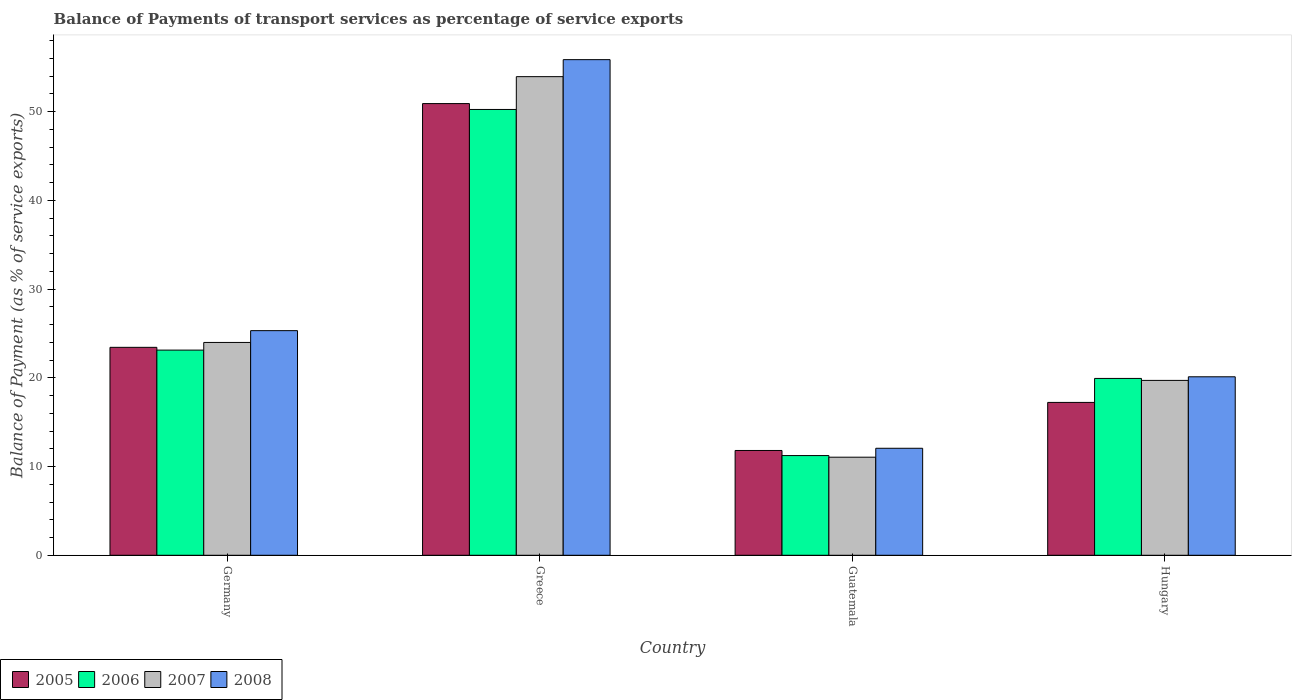How many groups of bars are there?
Your answer should be compact. 4. Are the number of bars per tick equal to the number of legend labels?
Ensure brevity in your answer.  Yes. How many bars are there on the 2nd tick from the left?
Give a very brief answer. 4. What is the balance of payments of transport services in 2008 in Hungary?
Ensure brevity in your answer.  20.12. Across all countries, what is the maximum balance of payments of transport services in 2005?
Provide a succinct answer. 50.92. Across all countries, what is the minimum balance of payments of transport services in 2007?
Make the answer very short. 11.06. In which country was the balance of payments of transport services in 2006 minimum?
Give a very brief answer. Guatemala. What is the total balance of payments of transport services in 2006 in the graph?
Keep it short and to the point. 104.55. What is the difference between the balance of payments of transport services in 2005 in Guatemala and that in Hungary?
Give a very brief answer. -5.42. What is the difference between the balance of payments of transport services in 2006 in Hungary and the balance of payments of transport services in 2008 in Guatemala?
Make the answer very short. 7.87. What is the average balance of payments of transport services in 2007 per country?
Offer a very short reply. 27.18. What is the difference between the balance of payments of transport services of/in 2006 and balance of payments of transport services of/in 2005 in Germany?
Give a very brief answer. -0.31. In how many countries, is the balance of payments of transport services in 2008 greater than 14 %?
Your answer should be compact. 3. What is the ratio of the balance of payments of transport services in 2006 in Guatemala to that in Hungary?
Make the answer very short. 0.56. Is the balance of payments of transport services in 2007 in Guatemala less than that in Hungary?
Provide a short and direct response. Yes. Is the difference between the balance of payments of transport services in 2006 in Germany and Guatemala greater than the difference between the balance of payments of transport services in 2005 in Germany and Guatemala?
Provide a short and direct response. Yes. What is the difference between the highest and the second highest balance of payments of transport services in 2006?
Provide a succinct answer. 30.32. What is the difference between the highest and the lowest balance of payments of transport services in 2006?
Ensure brevity in your answer.  39.02. Is the sum of the balance of payments of transport services in 2007 in Germany and Guatemala greater than the maximum balance of payments of transport services in 2008 across all countries?
Provide a short and direct response. No. Is it the case that in every country, the sum of the balance of payments of transport services in 2007 and balance of payments of transport services in 2008 is greater than the sum of balance of payments of transport services in 2005 and balance of payments of transport services in 2006?
Make the answer very short. No. What does the 4th bar from the left in Hungary represents?
Your answer should be very brief. 2008. How many countries are there in the graph?
Your response must be concise. 4. What is the difference between two consecutive major ticks on the Y-axis?
Offer a very short reply. 10. Does the graph contain any zero values?
Provide a succinct answer. No. Does the graph contain grids?
Your answer should be very brief. No. How many legend labels are there?
Your answer should be very brief. 4. What is the title of the graph?
Your answer should be compact. Balance of Payments of transport services as percentage of service exports. What is the label or title of the X-axis?
Make the answer very short. Country. What is the label or title of the Y-axis?
Your response must be concise. Balance of Payment (as % of service exports). What is the Balance of Payment (as % of service exports) in 2005 in Germany?
Your answer should be compact. 23.44. What is the Balance of Payment (as % of service exports) of 2006 in Germany?
Offer a very short reply. 23.13. What is the Balance of Payment (as % of service exports) of 2007 in Germany?
Your response must be concise. 23.99. What is the Balance of Payment (as % of service exports) in 2008 in Germany?
Keep it short and to the point. 25.32. What is the Balance of Payment (as % of service exports) of 2005 in Greece?
Your answer should be very brief. 50.92. What is the Balance of Payment (as % of service exports) of 2006 in Greece?
Ensure brevity in your answer.  50.25. What is the Balance of Payment (as % of service exports) of 2007 in Greece?
Your answer should be very brief. 53.95. What is the Balance of Payment (as % of service exports) in 2008 in Greece?
Offer a very short reply. 55.87. What is the Balance of Payment (as % of service exports) in 2005 in Guatemala?
Your answer should be very brief. 11.81. What is the Balance of Payment (as % of service exports) of 2006 in Guatemala?
Give a very brief answer. 11.24. What is the Balance of Payment (as % of service exports) of 2007 in Guatemala?
Ensure brevity in your answer.  11.06. What is the Balance of Payment (as % of service exports) of 2008 in Guatemala?
Give a very brief answer. 12.06. What is the Balance of Payment (as % of service exports) in 2005 in Hungary?
Make the answer very short. 17.23. What is the Balance of Payment (as % of service exports) in 2006 in Hungary?
Keep it short and to the point. 19.93. What is the Balance of Payment (as % of service exports) of 2007 in Hungary?
Offer a very short reply. 19.71. What is the Balance of Payment (as % of service exports) of 2008 in Hungary?
Offer a very short reply. 20.12. Across all countries, what is the maximum Balance of Payment (as % of service exports) of 2005?
Your answer should be very brief. 50.92. Across all countries, what is the maximum Balance of Payment (as % of service exports) of 2006?
Make the answer very short. 50.25. Across all countries, what is the maximum Balance of Payment (as % of service exports) in 2007?
Keep it short and to the point. 53.95. Across all countries, what is the maximum Balance of Payment (as % of service exports) in 2008?
Offer a terse response. 55.87. Across all countries, what is the minimum Balance of Payment (as % of service exports) of 2005?
Provide a succinct answer. 11.81. Across all countries, what is the minimum Balance of Payment (as % of service exports) of 2006?
Your answer should be compact. 11.24. Across all countries, what is the minimum Balance of Payment (as % of service exports) in 2007?
Give a very brief answer. 11.06. Across all countries, what is the minimum Balance of Payment (as % of service exports) of 2008?
Your response must be concise. 12.06. What is the total Balance of Payment (as % of service exports) of 2005 in the graph?
Your answer should be compact. 103.4. What is the total Balance of Payment (as % of service exports) of 2006 in the graph?
Provide a succinct answer. 104.55. What is the total Balance of Payment (as % of service exports) in 2007 in the graph?
Give a very brief answer. 108.71. What is the total Balance of Payment (as % of service exports) of 2008 in the graph?
Make the answer very short. 113.37. What is the difference between the Balance of Payment (as % of service exports) of 2005 in Germany and that in Greece?
Give a very brief answer. -27.48. What is the difference between the Balance of Payment (as % of service exports) in 2006 in Germany and that in Greece?
Offer a terse response. -27.13. What is the difference between the Balance of Payment (as % of service exports) in 2007 in Germany and that in Greece?
Your answer should be very brief. -29.96. What is the difference between the Balance of Payment (as % of service exports) in 2008 in Germany and that in Greece?
Provide a short and direct response. -30.55. What is the difference between the Balance of Payment (as % of service exports) in 2005 in Germany and that in Guatemala?
Provide a short and direct response. 11.63. What is the difference between the Balance of Payment (as % of service exports) in 2006 in Germany and that in Guatemala?
Your answer should be compact. 11.89. What is the difference between the Balance of Payment (as % of service exports) of 2007 in Germany and that in Guatemala?
Provide a succinct answer. 12.93. What is the difference between the Balance of Payment (as % of service exports) of 2008 in Germany and that in Guatemala?
Your answer should be very brief. 13.26. What is the difference between the Balance of Payment (as % of service exports) in 2005 in Germany and that in Hungary?
Offer a very short reply. 6.21. What is the difference between the Balance of Payment (as % of service exports) in 2006 in Germany and that in Hungary?
Provide a short and direct response. 3.19. What is the difference between the Balance of Payment (as % of service exports) of 2007 in Germany and that in Hungary?
Ensure brevity in your answer.  4.28. What is the difference between the Balance of Payment (as % of service exports) in 2008 in Germany and that in Hungary?
Offer a terse response. 5.2. What is the difference between the Balance of Payment (as % of service exports) of 2005 in Greece and that in Guatemala?
Your response must be concise. 39.1. What is the difference between the Balance of Payment (as % of service exports) of 2006 in Greece and that in Guatemala?
Provide a short and direct response. 39.02. What is the difference between the Balance of Payment (as % of service exports) of 2007 in Greece and that in Guatemala?
Offer a terse response. 42.9. What is the difference between the Balance of Payment (as % of service exports) in 2008 in Greece and that in Guatemala?
Provide a succinct answer. 43.81. What is the difference between the Balance of Payment (as % of service exports) of 2005 in Greece and that in Hungary?
Your response must be concise. 33.69. What is the difference between the Balance of Payment (as % of service exports) of 2006 in Greece and that in Hungary?
Provide a succinct answer. 30.32. What is the difference between the Balance of Payment (as % of service exports) in 2007 in Greece and that in Hungary?
Ensure brevity in your answer.  34.24. What is the difference between the Balance of Payment (as % of service exports) in 2008 in Greece and that in Hungary?
Give a very brief answer. 35.75. What is the difference between the Balance of Payment (as % of service exports) of 2005 in Guatemala and that in Hungary?
Ensure brevity in your answer.  -5.42. What is the difference between the Balance of Payment (as % of service exports) in 2006 in Guatemala and that in Hungary?
Offer a very short reply. -8.7. What is the difference between the Balance of Payment (as % of service exports) in 2007 in Guatemala and that in Hungary?
Keep it short and to the point. -8.66. What is the difference between the Balance of Payment (as % of service exports) in 2008 in Guatemala and that in Hungary?
Your answer should be compact. -8.06. What is the difference between the Balance of Payment (as % of service exports) of 2005 in Germany and the Balance of Payment (as % of service exports) of 2006 in Greece?
Offer a terse response. -26.81. What is the difference between the Balance of Payment (as % of service exports) in 2005 in Germany and the Balance of Payment (as % of service exports) in 2007 in Greece?
Keep it short and to the point. -30.51. What is the difference between the Balance of Payment (as % of service exports) in 2005 in Germany and the Balance of Payment (as % of service exports) in 2008 in Greece?
Make the answer very short. -32.43. What is the difference between the Balance of Payment (as % of service exports) of 2006 in Germany and the Balance of Payment (as % of service exports) of 2007 in Greece?
Offer a terse response. -30.83. What is the difference between the Balance of Payment (as % of service exports) in 2006 in Germany and the Balance of Payment (as % of service exports) in 2008 in Greece?
Ensure brevity in your answer.  -32.74. What is the difference between the Balance of Payment (as % of service exports) in 2007 in Germany and the Balance of Payment (as % of service exports) in 2008 in Greece?
Make the answer very short. -31.88. What is the difference between the Balance of Payment (as % of service exports) in 2005 in Germany and the Balance of Payment (as % of service exports) in 2006 in Guatemala?
Your answer should be compact. 12.2. What is the difference between the Balance of Payment (as % of service exports) of 2005 in Germany and the Balance of Payment (as % of service exports) of 2007 in Guatemala?
Your response must be concise. 12.38. What is the difference between the Balance of Payment (as % of service exports) of 2005 in Germany and the Balance of Payment (as % of service exports) of 2008 in Guatemala?
Keep it short and to the point. 11.38. What is the difference between the Balance of Payment (as % of service exports) of 2006 in Germany and the Balance of Payment (as % of service exports) of 2007 in Guatemala?
Your answer should be very brief. 12.07. What is the difference between the Balance of Payment (as % of service exports) of 2006 in Germany and the Balance of Payment (as % of service exports) of 2008 in Guatemala?
Your answer should be very brief. 11.06. What is the difference between the Balance of Payment (as % of service exports) in 2007 in Germany and the Balance of Payment (as % of service exports) in 2008 in Guatemala?
Give a very brief answer. 11.93. What is the difference between the Balance of Payment (as % of service exports) in 2005 in Germany and the Balance of Payment (as % of service exports) in 2006 in Hungary?
Give a very brief answer. 3.51. What is the difference between the Balance of Payment (as % of service exports) in 2005 in Germany and the Balance of Payment (as % of service exports) in 2007 in Hungary?
Provide a succinct answer. 3.73. What is the difference between the Balance of Payment (as % of service exports) of 2005 in Germany and the Balance of Payment (as % of service exports) of 2008 in Hungary?
Offer a terse response. 3.32. What is the difference between the Balance of Payment (as % of service exports) of 2006 in Germany and the Balance of Payment (as % of service exports) of 2007 in Hungary?
Offer a terse response. 3.41. What is the difference between the Balance of Payment (as % of service exports) in 2006 in Germany and the Balance of Payment (as % of service exports) in 2008 in Hungary?
Keep it short and to the point. 3.01. What is the difference between the Balance of Payment (as % of service exports) of 2007 in Germany and the Balance of Payment (as % of service exports) of 2008 in Hungary?
Keep it short and to the point. 3.87. What is the difference between the Balance of Payment (as % of service exports) in 2005 in Greece and the Balance of Payment (as % of service exports) in 2006 in Guatemala?
Your answer should be compact. 39.68. What is the difference between the Balance of Payment (as % of service exports) of 2005 in Greece and the Balance of Payment (as % of service exports) of 2007 in Guatemala?
Your answer should be very brief. 39.86. What is the difference between the Balance of Payment (as % of service exports) of 2005 in Greece and the Balance of Payment (as % of service exports) of 2008 in Guatemala?
Your answer should be compact. 38.85. What is the difference between the Balance of Payment (as % of service exports) of 2006 in Greece and the Balance of Payment (as % of service exports) of 2007 in Guatemala?
Make the answer very short. 39.2. What is the difference between the Balance of Payment (as % of service exports) of 2006 in Greece and the Balance of Payment (as % of service exports) of 2008 in Guatemala?
Offer a terse response. 38.19. What is the difference between the Balance of Payment (as % of service exports) of 2007 in Greece and the Balance of Payment (as % of service exports) of 2008 in Guatemala?
Offer a very short reply. 41.89. What is the difference between the Balance of Payment (as % of service exports) in 2005 in Greece and the Balance of Payment (as % of service exports) in 2006 in Hungary?
Your answer should be compact. 30.98. What is the difference between the Balance of Payment (as % of service exports) in 2005 in Greece and the Balance of Payment (as % of service exports) in 2007 in Hungary?
Offer a terse response. 31.2. What is the difference between the Balance of Payment (as % of service exports) in 2005 in Greece and the Balance of Payment (as % of service exports) in 2008 in Hungary?
Provide a succinct answer. 30.8. What is the difference between the Balance of Payment (as % of service exports) of 2006 in Greece and the Balance of Payment (as % of service exports) of 2007 in Hungary?
Offer a terse response. 30.54. What is the difference between the Balance of Payment (as % of service exports) of 2006 in Greece and the Balance of Payment (as % of service exports) of 2008 in Hungary?
Offer a very short reply. 30.13. What is the difference between the Balance of Payment (as % of service exports) of 2007 in Greece and the Balance of Payment (as % of service exports) of 2008 in Hungary?
Keep it short and to the point. 33.83. What is the difference between the Balance of Payment (as % of service exports) in 2005 in Guatemala and the Balance of Payment (as % of service exports) in 2006 in Hungary?
Your answer should be compact. -8.12. What is the difference between the Balance of Payment (as % of service exports) in 2005 in Guatemala and the Balance of Payment (as % of service exports) in 2007 in Hungary?
Give a very brief answer. -7.9. What is the difference between the Balance of Payment (as % of service exports) in 2005 in Guatemala and the Balance of Payment (as % of service exports) in 2008 in Hungary?
Provide a succinct answer. -8.31. What is the difference between the Balance of Payment (as % of service exports) in 2006 in Guatemala and the Balance of Payment (as % of service exports) in 2007 in Hungary?
Make the answer very short. -8.47. What is the difference between the Balance of Payment (as % of service exports) of 2006 in Guatemala and the Balance of Payment (as % of service exports) of 2008 in Hungary?
Your answer should be very brief. -8.88. What is the difference between the Balance of Payment (as % of service exports) in 2007 in Guatemala and the Balance of Payment (as % of service exports) in 2008 in Hungary?
Provide a short and direct response. -9.06. What is the average Balance of Payment (as % of service exports) of 2005 per country?
Your answer should be compact. 25.85. What is the average Balance of Payment (as % of service exports) in 2006 per country?
Give a very brief answer. 26.14. What is the average Balance of Payment (as % of service exports) in 2007 per country?
Give a very brief answer. 27.18. What is the average Balance of Payment (as % of service exports) of 2008 per country?
Provide a short and direct response. 28.34. What is the difference between the Balance of Payment (as % of service exports) in 2005 and Balance of Payment (as % of service exports) in 2006 in Germany?
Ensure brevity in your answer.  0.31. What is the difference between the Balance of Payment (as % of service exports) in 2005 and Balance of Payment (as % of service exports) in 2007 in Germany?
Keep it short and to the point. -0.55. What is the difference between the Balance of Payment (as % of service exports) of 2005 and Balance of Payment (as % of service exports) of 2008 in Germany?
Make the answer very short. -1.88. What is the difference between the Balance of Payment (as % of service exports) of 2006 and Balance of Payment (as % of service exports) of 2007 in Germany?
Your response must be concise. -0.86. What is the difference between the Balance of Payment (as % of service exports) in 2006 and Balance of Payment (as % of service exports) in 2008 in Germany?
Your answer should be very brief. -2.19. What is the difference between the Balance of Payment (as % of service exports) of 2007 and Balance of Payment (as % of service exports) of 2008 in Germany?
Offer a very short reply. -1.33. What is the difference between the Balance of Payment (as % of service exports) in 2005 and Balance of Payment (as % of service exports) in 2006 in Greece?
Give a very brief answer. 0.66. What is the difference between the Balance of Payment (as % of service exports) of 2005 and Balance of Payment (as % of service exports) of 2007 in Greece?
Give a very brief answer. -3.04. What is the difference between the Balance of Payment (as % of service exports) of 2005 and Balance of Payment (as % of service exports) of 2008 in Greece?
Offer a terse response. -4.95. What is the difference between the Balance of Payment (as % of service exports) in 2006 and Balance of Payment (as % of service exports) in 2007 in Greece?
Offer a terse response. -3.7. What is the difference between the Balance of Payment (as % of service exports) in 2006 and Balance of Payment (as % of service exports) in 2008 in Greece?
Your response must be concise. -5.61. What is the difference between the Balance of Payment (as % of service exports) in 2007 and Balance of Payment (as % of service exports) in 2008 in Greece?
Make the answer very short. -1.92. What is the difference between the Balance of Payment (as % of service exports) of 2005 and Balance of Payment (as % of service exports) of 2006 in Guatemala?
Offer a terse response. 0.58. What is the difference between the Balance of Payment (as % of service exports) in 2005 and Balance of Payment (as % of service exports) in 2007 in Guatemala?
Your answer should be very brief. 0.76. What is the difference between the Balance of Payment (as % of service exports) in 2005 and Balance of Payment (as % of service exports) in 2008 in Guatemala?
Ensure brevity in your answer.  -0.25. What is the difference between the Balance of Payment (as % of service exports) in 2006 and Balance of Payment (as % of service exports) in 2007 in Guatemala?
Your answer should be very brief. 0.18. What is the difference between the Balance of Payment (as % of service exports) in 2006 and Balance of Payment (as % of service exports) in 2008 in Guatemala?
Offer a terse response. -0.82. What is the difference between the Balance of Payment (as % of service exports) of 2007 and Balance of Payment (as % of service exports) of 2008 in Guatemala?
Ensure brevity in your answer.  -1.01. What is the difference between the Balance of Payment (as % of service exports) of 2005 and Balance of Payment (as % of service exports) of 2006 in Hungary?
Offer a terse response. -2.7. What is the difference between the Balance of Payment (as % of service exports) of 2005 and Balance of Payment (as % of service exports) of 2007 in Hungary?
Give a very brief answer. -2.48. What is the difference between the Balance of Payment (as % of service exports) of 2005 and Balance of Payment (as % of service exports) of 2008 in Hungary?
Ensure brevity in your answer.  -2.89. What is the difference between the Balance of Payment (as % of service exports) of 2006 and Balance of Payment (as % of service exports) of 2007 in Hungary?
Ensure brevity in your answer.  0.22. What is the difference between the Balance of Payment (as % of service exports) of 2006 and Balance of Payment (as % of service exports) of 2008 in Hungary?
Keep it short and to the point. -0.19. What is the difference between the Balance of Payment (as % of service exports) in 2007 and Balance of Payment (as % of service exports) in 2008 in Hungary?
Provide a short and direct response. -0.41. What is the ratio of the Balance of Payment (as % of service exports) in 2005 in Germany to that in Greece?
Your answer should be compact. 0.46. What is the ratio of the Balance of Payment (as % of service exports) of 2006 in Germany to that in Greece?
Give a very brief answer. 0.46. What is the ratio of the Balance of Payment (as % of service exports) in 2007 in Germany to that in Greece?
Provide a short and direct response. 0.44. What is the ratio of the Balance of Payment (as % of service exports) in 2008 in Germany to that in Greece?
Offer a very short reply. 0.45. What is the ratio of the Balance of Payment (as % of service exports) of 2005 in Germany to that in Guatemala?
Ensure brevity in your answer.  1.98. What is the ratio of the Balance of Payment (as % of service exports) of 2006 in Germany to that in Guatemala?
Provide a short and direct response. 2.06. What is the ratio of the Balance of Payment (as % of service exports) of 2007 in Germany to that in Guatemala?
Ensure brevity in your answer.  2.17. What is the ratio of the Balance of Payment (as % of service exports) in 2008 in Germany to that in Guatemala?
Give a very brief answer. 2.1. What is the ratio of the Balance of Payment (as % of service exports) of 2005 in Germany to that in Hungary?
Your response must be concise. 1.36. What is the ratio of the Balance of Payment (as % of service exports) of 2006 in Germany to that in Hungary?
Make the answer very short. 1.16. What is the ratio of the Balance of Payment (as % of service exports) of 2007 in Germany to that in Hungary?
Your response must be concise. 1.22. What is the ratio of the Balance of Payment (as % of service exports) in 2008 in Germany to that in Hungary?
Your answer should be compact. 1.26. What is the ratio of the Balance of Payment (as % of service exports) of 2005 in Greece to that in Guatemala?
Offer a very short reply. 4.31. What is the ratio of the Balance of Payment (as % of service exports) in 2006 in Greece to that in Guatemala?
Offer a terse response. 4.47. What is the ratio of the Balance of Payment (as % of service exports) of 2007 in Greece to that in Guatemala?
Ensure brevity in your answer.  4.88. What is the ratio of the Balance of Payment (as % of service exports) in 2008 in Greece to that in Guatemala?
Provide a short and direct response. 4.63. What is the ratio of the Balance of Payment (as % of service exports) of 2005 in Greece to that in Hungary?
Your answer should be compact. 2.96. What is the ratio of the Balance of Payment (as % of service exports) of 2006 in Greece to that in Hungary?
Ensure brevity in your answer.  2.52. What is the ratio of the Balance of Payment (as % of service exports) in 2007 in Greece to that in Hungary?
Make the answer very short. 2.74. What is the ratio of the Balance of Payment (as % of service exports) in 2008 in Greece to that in Hungary?
Your answer should be compact. 2.78. What is the ratio of the Balance of Payment (as % of service exports) of 2005 in Guatemala to that in Hungary?
Offer a very short reply. 0.69. What is the ratio of the Balance of Payment (as % of service exports) of 2006 in Guatemala to that in Hungary?
Provide a succinct answer. 0.56. What is the ratio of the Balance of Payment (as % of service exports) in 2007 in Guatemala to that in Hungary?
Make the answer very short. 0.56. What is the ratio of the Balance of Payment (as % of service exports) of 2008 in Guatemala to that in Hungary?
Keep it short and to the point. 0.6. What is the difference between the highest and the second highest Balance of Payment (as % of service exports) in 2005?
Your answer should be very brief. 27.48. What is the difference between the highest and the second highest Balance of Payment (as % of service exports) of 2006?
Your response must be concise. 27.13. What is the difference between the highest and the second highest Balance of Payment (as % of service exports) of 2007?
Make the answer very short. 29.96. What is the difference between the highest and the second highest Balance of Payment (as % of service exports) in 2008?
Ensure brevity in your answer.  30.55. What is the difference between the highest and the lowest Balance of Payment (as % of service exports) in 2005?
Offer a very short reply. 39.1. What is the difference between the highest and the lowest Balance of Payment (as % of service exports) of 2006?
Your answer should be very brief. 39.02. What is the difference between the highest and the lowest Balance of Payment (as % of service exports) of 2007?
Your response must be concise. 42.9. What is the difference between the highest and the lowest Balance of Payment (as % of service exports) of 2008?
Your answer should be very brief. 43.81. 